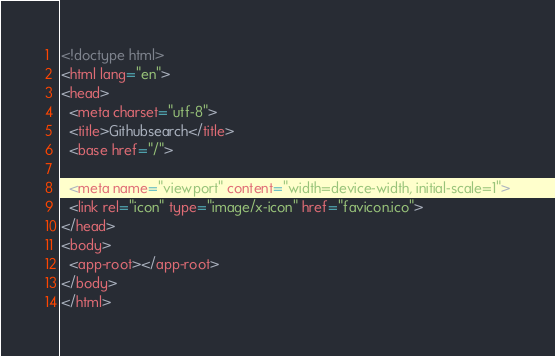<code> <loc_0><loc_0><loc_500><loc_500><_HTML_><!doctype html>
<html lang="en">
<head>
  <meta charset="utf-8">
  <title>Githubsearch</title>
  <base href="/">

  <meta name="viewport" content="width=device-width, initial-scale=1">
  <link rel="icon" type="image/x-icon" href="favicon.ico">
</head>
<body>
  <app-root></app-root>
</body>
</html>
</code> 